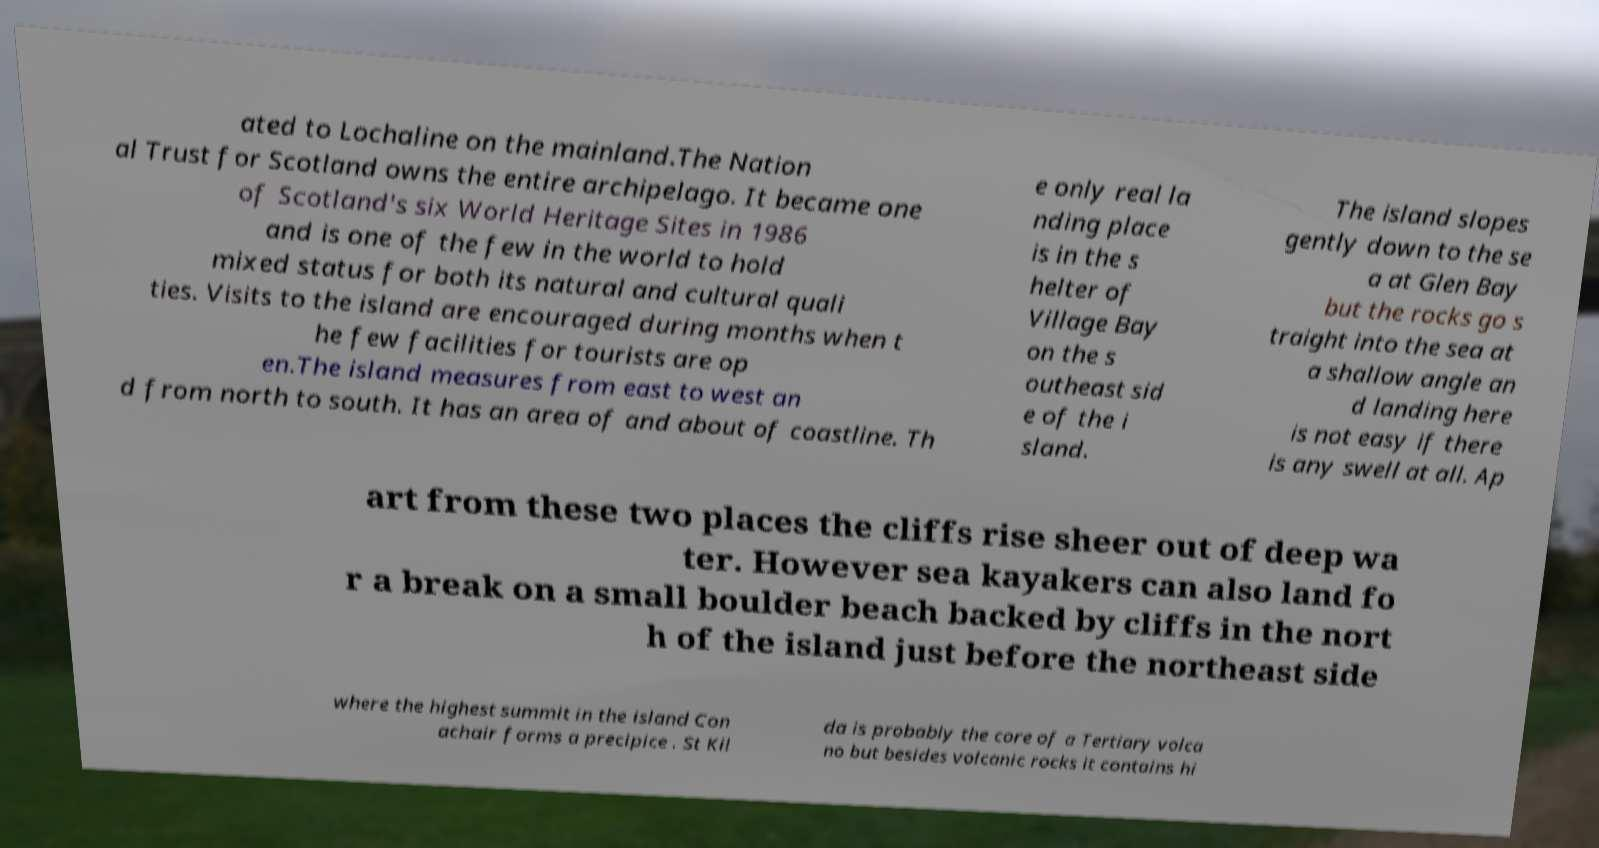Please identify and transcribe the text found in this image. ated to Lochaline on the mainland.The Nation al Trust for Scotland owns the entire archipelago. It became one of Scotland's six World Heritage Sites in 1986 and is one of the few in the world to hold mixed status for both its natural and cultural quali ties. Visits to the island are encouraged during months when t he few facilities for tourists are op en.The island measures from east to west an d from north to south. It has an area of and about of coastline. Th e only real la nding place is in the s helter of Village Bay on the s outheast sid e of the i sland. The island slopes gently down to the se a at Glen Bay but the rocks go s traight into the sea at a shallow angle an d landing here is not easy if there is any swell at all. Ap art from these two places the cliffs rise sheer out of deep wa ter. However sea kayakers can also land fo r a break on a small boulder beach backed by cliffs in the nort h of the island just before the northeast side where the highest summit in the island Con achair forms a precipice . St Kil da is probably the core of a Tertiary volca no but besides volcanic rocks it contains hi 